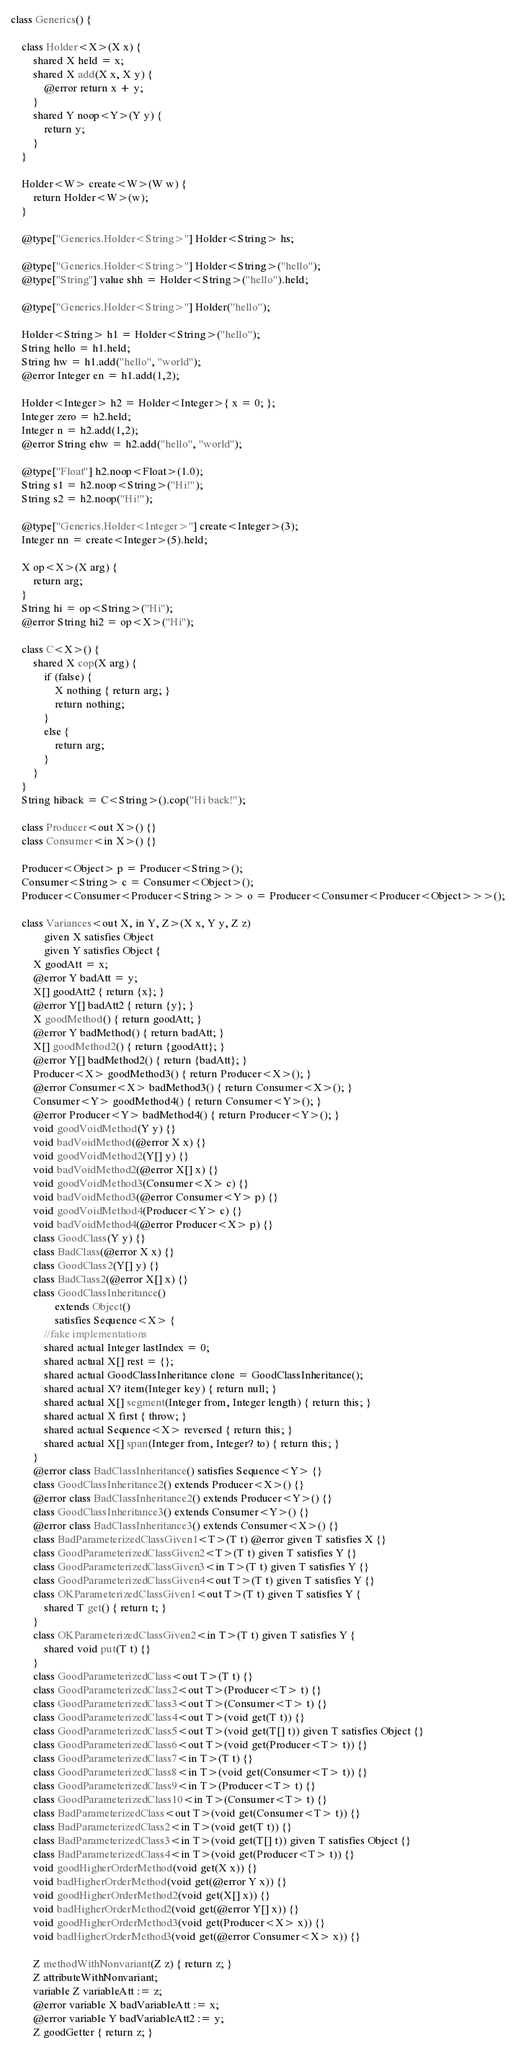Convert code to text. <code><loc_0><loc_0><loc_500><loc_500><_Ceylon_>class Generics() {
    
    class Holder<X>(X x) {
        shared X held = x;
        shared X add(X x, X y) {
            @error return x + y;
        }
        shared Y noop<Y>(Y y) {
            return y;
        }
    }
    
    Holder<W> create<W>(W w) {
        return Holder<W>(w);
    }
    
    @type["Generics.Holder<String>"] Holder<String> hs;
    
    @type["Generics.Holder<String>"] Holder<String>("hello");
    @type["String"] value shh = Holder<String>("hello").held;
    
    @type["Generics.Holder<String>"] Holder("hello");
    
    Holder<String> h1 = Holder<String>("hello");
    String hello = h1.held;
    String hw = h1.add("hello", "world");
    @error Integer en = h1.add(1,2);
    
    Holder<Integer> h2 = Holder<Integer>{ x = 0; };
    Integer zero = h2.held;
    Integer n = h2.add(1,2);
    @error String ehw = h2.add("hello", "world");
    
    @type["Float"] h2.noop<Float>(1.0);
    String s1 = h2.noop<String>("Hi!");
    String s2 = h2.noop("Hi!");
    
    @type["Generics.Holder<Integer>"] create<Integer>(3);
    Integer nn = create<Integer>(5).held;
    
    X op<X>(X arg) {
        return arg;
    }
    String hi = op<String>("Hi");
    @error String hi2 = op<X>("Hi");
    
    class C<X>() {
        shared X cop(X arg) {
            if (false) {
                X nothing { return arg; }
                return nothing;
            }
            else {
                return arg;
            }
        }
    }
    String hiback = C<String>().cop("Hi back!");
    
    class Producer<out X>() {}
    class Consumer<in X>() {}
    
    Producer<Object> p = Producer<String>();
    Consumer<String> c = Consumer<Object>();
    Producer<Consumer<Producer<String>>> o = Producer<Consumer<Producer<Object>>>();
    
    class Variances<out X, in Y, Z>(X x, Y y, Z z) 
            given X satisfies Object
            given Y satisfies Object {
        X goodAtt = x;
        @error Y badAtt = y;
        X[] goodAtt2 { return {x}; }
        @error Y[] badAtt2 { return {y}; }
        X goodMethod() { return goodAtt; }
        @error Y badMethod() { return badAtt; }
        X[] goodMethod2() { return {goodAtt}; }
        @error Y[] badMethod2() { return {badAtt}; }
        Producer<X> goodMethod3() { return Producer<X>(); }
        @error Consumer<X> badMethod3() { return Consumer<X>(); }
        Consumer<Y> goodMethod4() { return Consumer<Y>(); }
        @error Producer<Y> badMethod4() { return Producer<Y>(); }
        void goodVoidMethod(Y y) {}
        void badVoidMethod(@error X x) {}
        void goodVoidMethod2(Y[] y) {}
        void badVoidMethod2(@error X[] x) {}
        void goodVoidMethod3(Consumer<X> c) {}
        void badVoidMethod3(@error Consumer<Y> p) {}
        void goodVoidMethod4(Producer<Y> c) {}
        void badVoidMethod4(@error Producer<X> p) {}
        class GoodClass(Y y) {}
        class BadClass(@error X x) {}
        class GoodClass2(Y[] y) {}
        class BadClass2(@error X[] x) {}
        class GoodClassInheritance() 
                extends Object() 
                satisfies Sequence<X> {
            //fake implementations
            shared actual Integer lastIndex = 0;
            shared actual X[] rest = {};
            shared actual GoodClassInheritance clone = GoodClassInheritance();
            shared actual X? item(Integer key) { return null; }
            shared actual X[] segment(Integer from, Integer length) { return this; }
            shared actual X first { throw; }
            shared actual Sequence<X> reversed { return this; }
            shared actual X[] span(Integer from, Integer? to) { return this; }
        }
        @error class BadClassInheritance() satisfies Sequence<Y> {}
        class GoodClassInheritance2() extends Producer<X>() {}
        @error class BadClassInheritance2() extends Producer<Y>() {}
        class GoodClassInheritance3() extends Consumer<Y>() {}
        @error class BadClassInheritance3() extends Consumer<X>() {}
        class BadParameterizedClassGiven1<T>(T t) @error given T satisfies X {}
        class GoodParameterizedClassGiven2<T>(T t) given T satisfies Y {}
        class GoodParameterizedClassGiven3<in T>(T t) given T satisfies Y {}
        class GoodParameterizedClassGiven4<out T>(T t) given T satisfies Y {}
        class OKParameterizedClassGiven1<out T>(T t) given T satisfies Y {
        	shared T get() { return t; }
        }
        class OKParameterizedClassGiven2<in T>(T t) given T satisfies Y {
        	shared void put(T t) {}
        }
        class GoodParameterizedClass<out T>(T t) {}
        class GoodParameterizedClass2<out T>(Producer<T> t) {}
        class GoodParameterizedClass3<out T>(Consumer<T> t) {}
        class GoodParameterizedClass4<out T>(void get(T t)) {}
        class GoodParameterizedClass5<out T>(void get(T[] t)) given T satisfies Object {}
        class GoodParameterizedClass6<out T>(void get(Producer<T> t)) {}
        class GoodParameterizedClass7<in T>(T t) {}
        class GoodParameterizedClass8<in T>(void get(Consumer<T> t)) {}
        class GoodParameterizedClass9<in T>(Producer<T> t) {}
        class GoodParameterizedClass10<in T>(Consumer<T> t) {}
        class BadParameterizedClass<out T>(void get(Consumer<T> t)) {}
        class BadParameterizedClass2<in T>(void get(T t)) {}
        class BadParameterizedClass3<in T>(void get(T[] t)) given T satisfies Object {}
        class BadParameterizedClass4<in T>(void get(Producer<T> t)) {}
        void goodHigherOrderMethod(void get(X x)) {}
        void badHigherOrderMethod(void get(@error Y x)) {}
        void goodHigherOrderMethod2(void get(X[] x)) {}
        void badHigherOrderMethod2(void get(@error Y[] x)) {}
        void goodHigherOrderMethod3(void get(Producer<X> x)) {}
        void badHigherOrderMethod3(void get(@error Consumer<X> x)) {}
        
        Z methodWithNonvariant(Z z) { return z; }
        Z attributeWithNonvariant;
        variable Z variableAtt := z;
        @error variable X badVariableAtt := x;
        @error variable Y badVariableAtt2 := y;
        Z goodGetter { return z; }</code> 